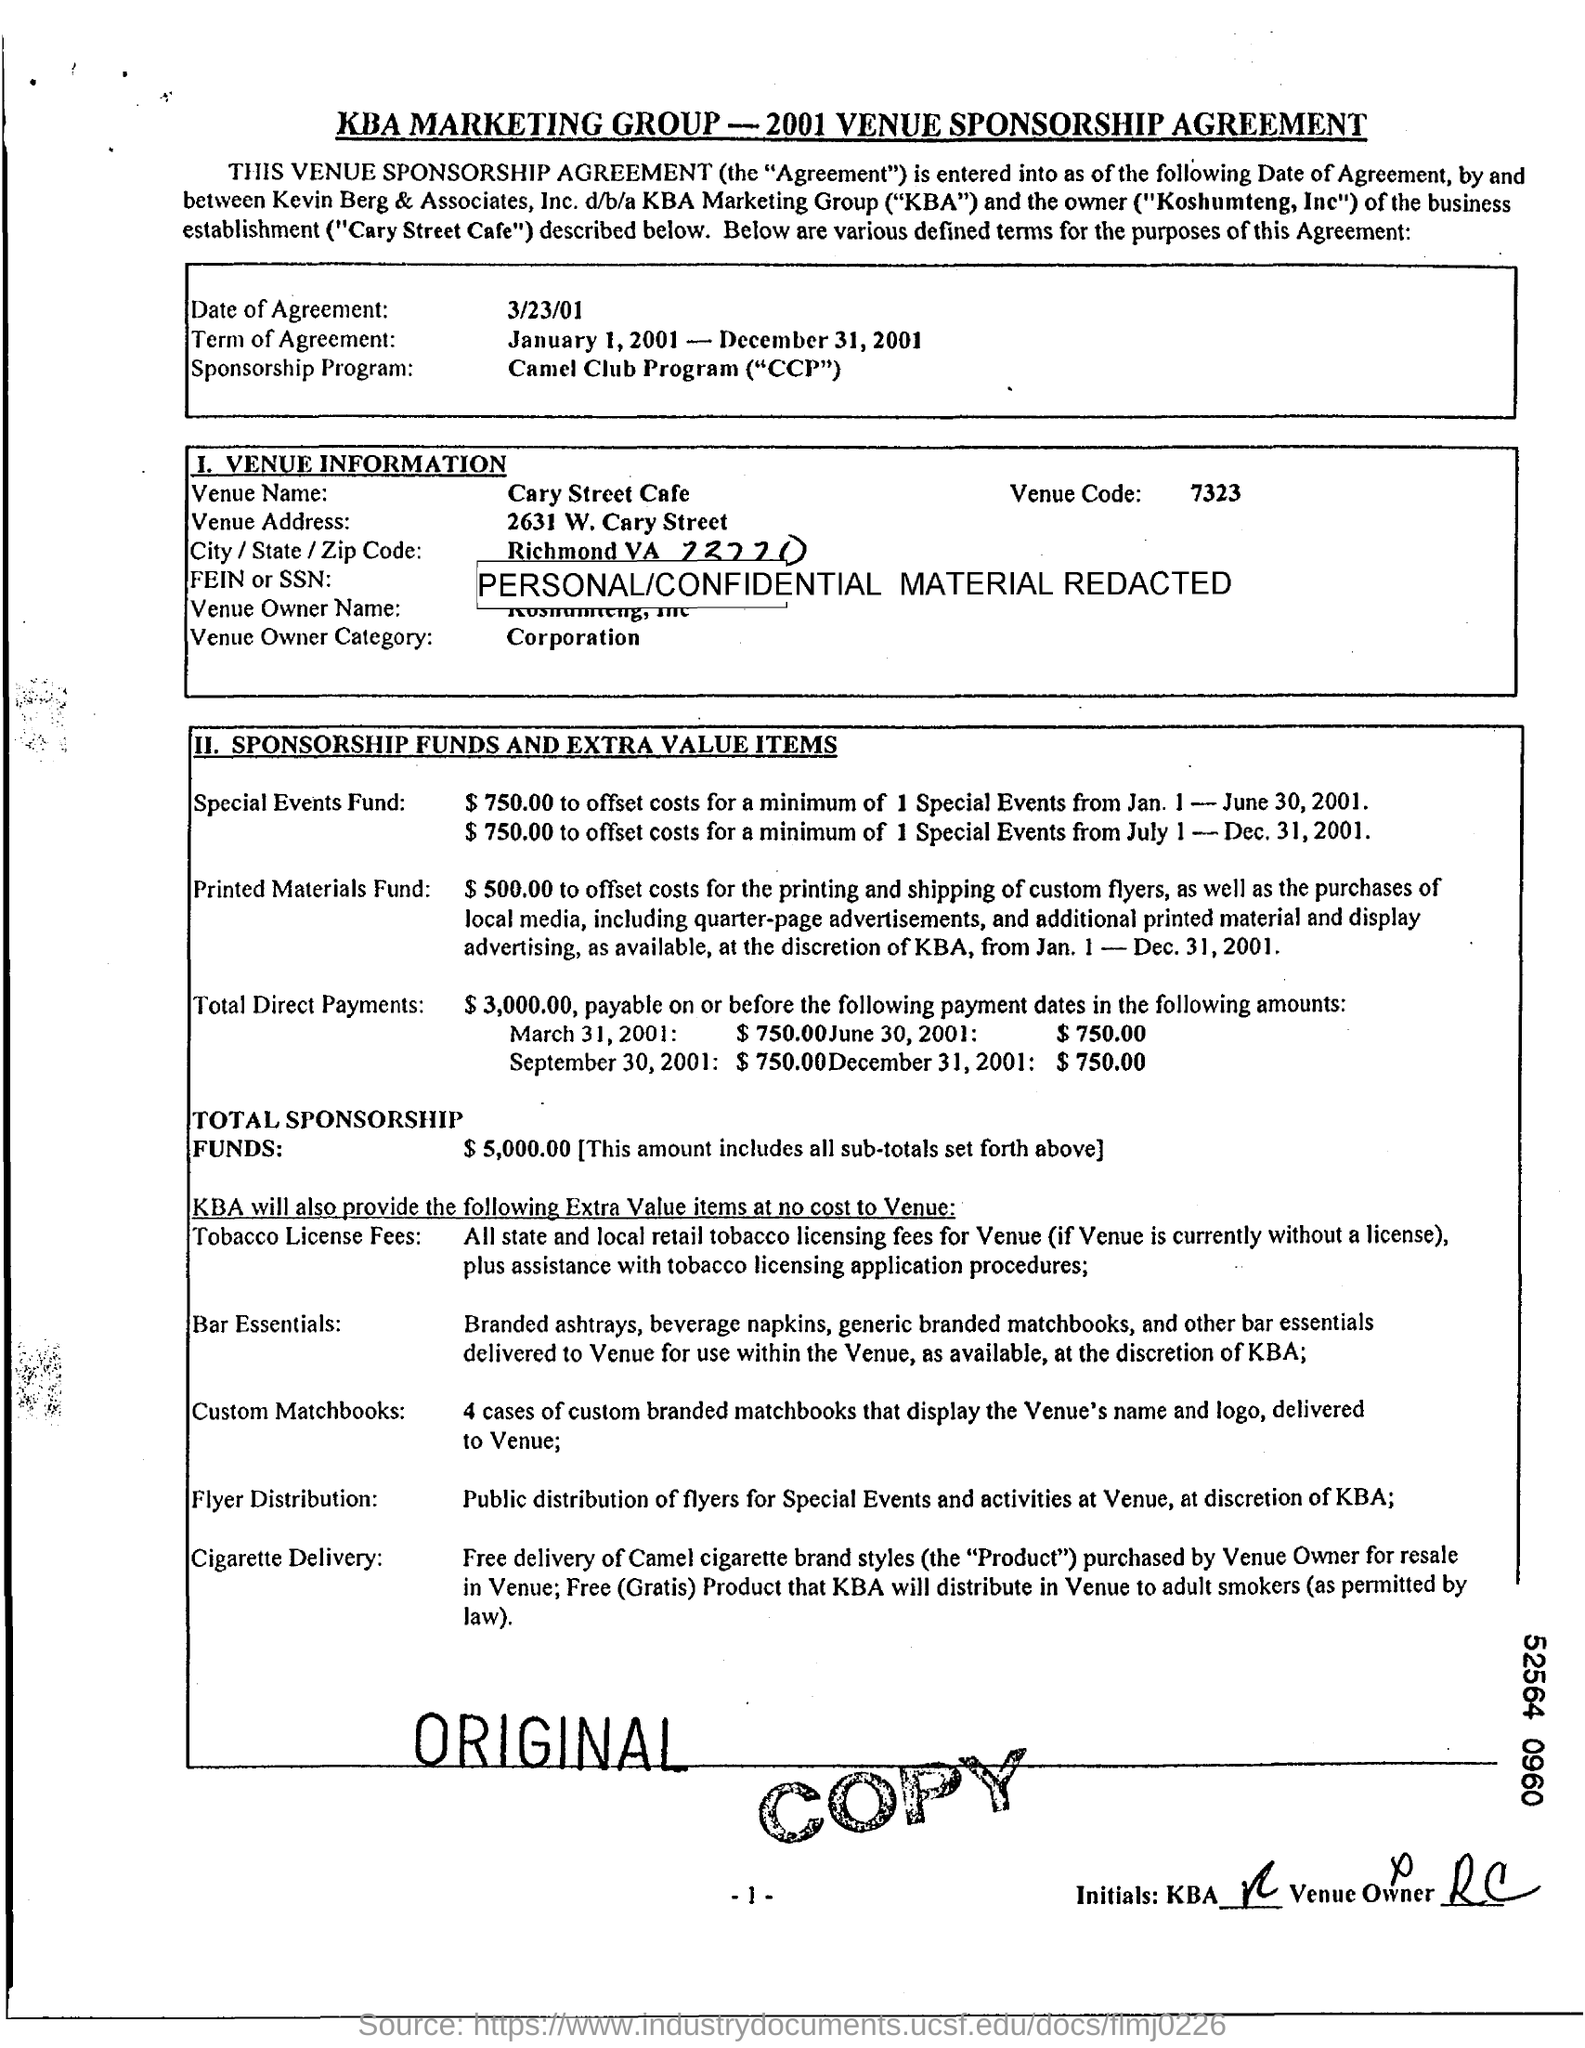What is the date of agreement?
Provide a succinct answer. 3/23/01. What is the term of agreement?
Ensure brevity in your answer.  January 1, 2001 - December 31, 2001. What is the venue code?
Ensure brevity in your answer.  7323. 